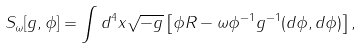<formula> <loc_0><loc_0><loc_500><loc_500>S _ { \omega } [ g , \phi ] = \int d ^ { 4 } x \sqrt { - g } \left [ \phi R - \omega \phi ^ { - 1 } g ^ { - 1 } ( d \phi , d \phi ) \right ] ,</formula> 